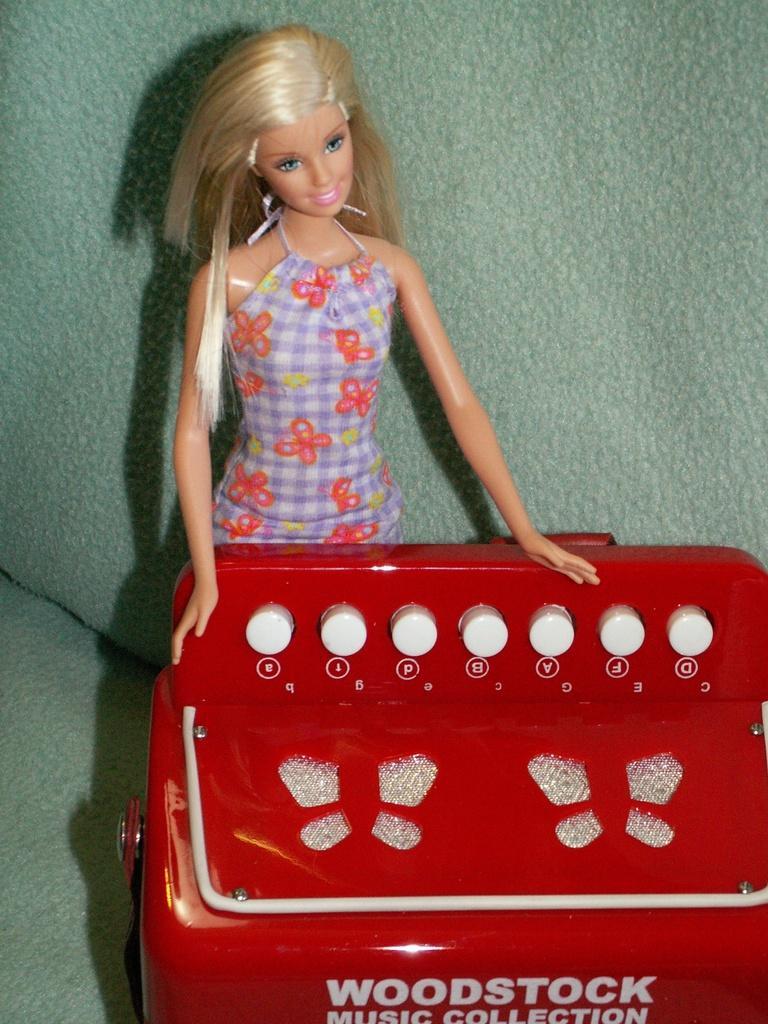In one or two sentences, can you explain what this image depicts? In this picture we can see a toy and we can find some text on the object. 